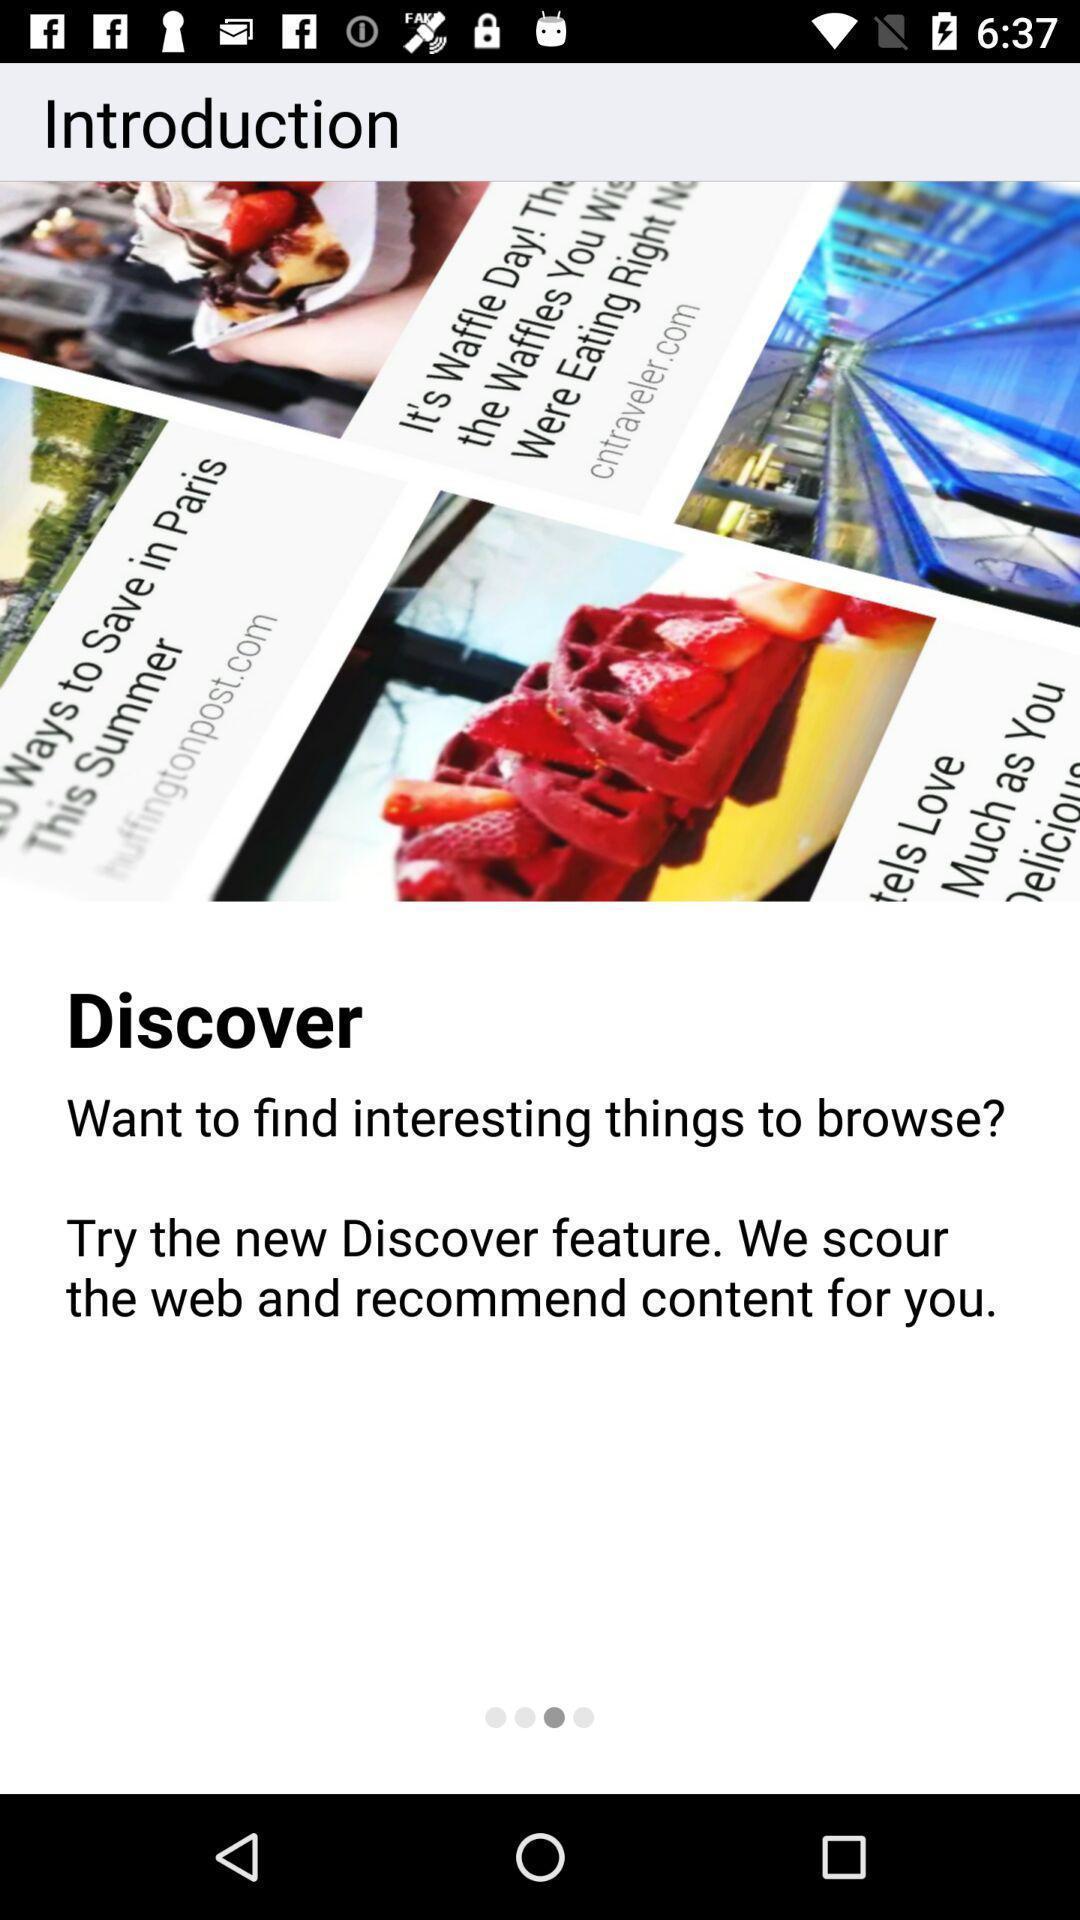Describe this image in words. Page displaying introduction information in a browsing application. 